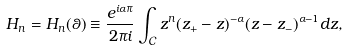Convert formula to latex. <formula><loc_0><loc_0><loc_500><loc_500>H _ { n } = H _ { n } ( \theta ) \equiv \frac { e ^ { i \alpha \pi } } { 2 \pi i } \int _ { \mathcal { C } } z ^ { n } ( z _ { + } - z ) ^ { - \alpha } ( z - z _ { - } ) ^ { \alpha - 1 } d z ,</formula> 